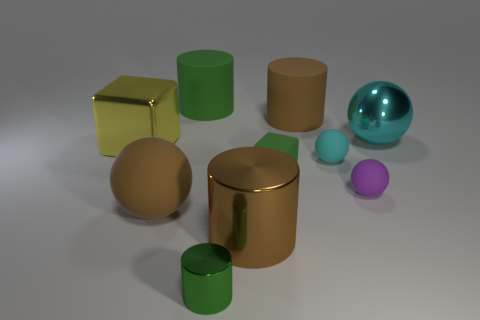Subtract all green cylinders. Subtract all green cubes. How many cylinders are left? 2 Subtract all cylinders. How many objects are left? 6 Add 8 purple rubber spheres. How many purple rubber spheres are left? 9 Add 5 tiny purple shiny cylinders. How many tiny purple shiny cylinders exist? 5 Subtract 0 purple blocks. How many objects are left? 10 Subtract all green matte objects. Subtract all green shiny blocks. How many objects are left? 8 